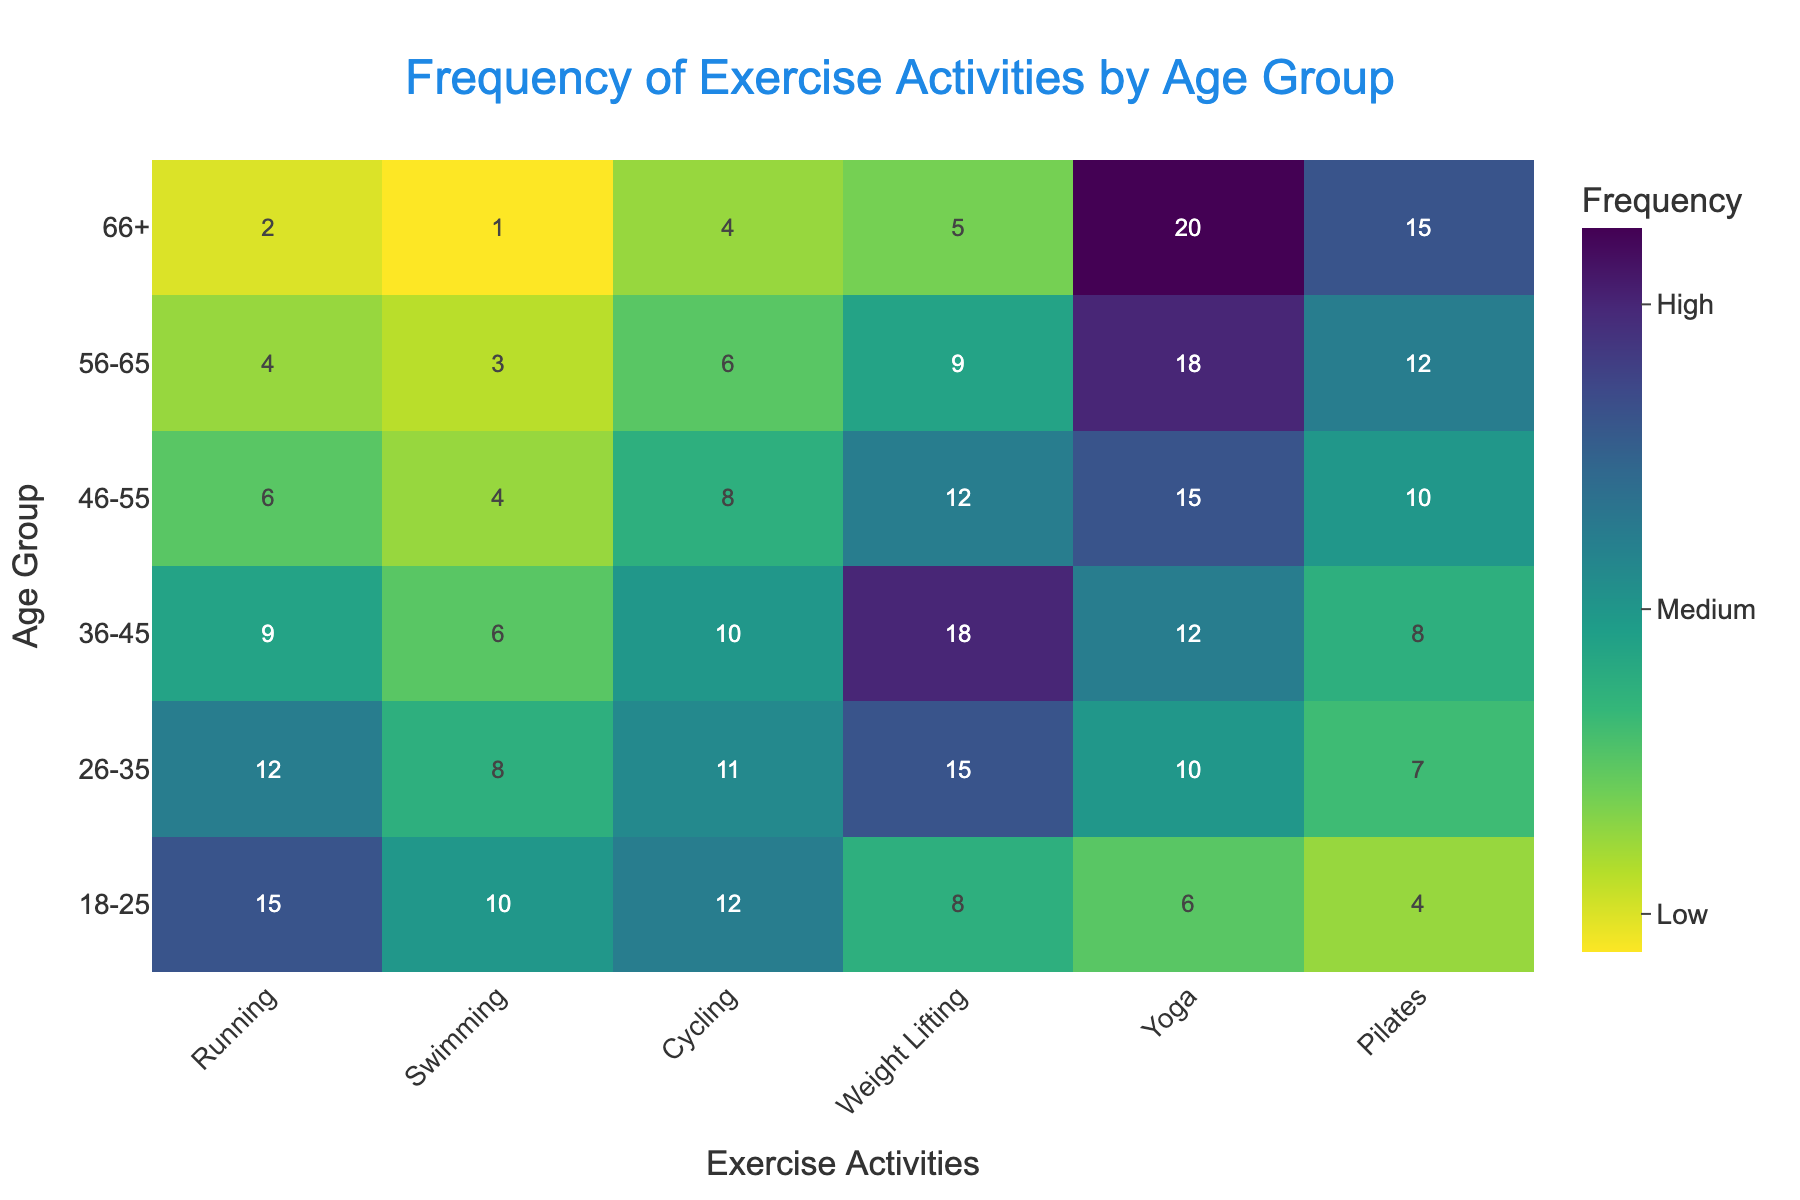What's the age group with the highest frequency of running? Look at the vertical axis for the highest frequency value in the 'Running' column
Answer: 18-25 What is the most frequent exercise activity for the age group 56-65? Locate the 56-65 age group row and find the highest value among exercise frequencies
Answer: Yoga How much more often do individuals aged 36-45 practice weight lifting compared to those aged 18-25? Compare the values in the 'Weight Lifting' column for age groups 36-45 and 18-25 (18 - 8 = 10)
Answer: 10 times more Which age group has the lowest frequency of swimming? Find the minimum value in the 'Swimming' column and identify the corresponding age group
Answer: 66+ On average, how many types of exercises do 26-35 year-olds engage in? Add all frequencies for 26-35 and divide by the number of exercise types ((12 + 8 + 11 + 15 + 10 + 7)/6 = 10.5)
Answer: 10.5 Is yoga more popular among individuals aged 46-55 or 66+? Compare the values in the 'Yoga' column for age groups 46-55 and 66+ (15 vs 20)
Answer: 66+ Which exercise activity has the highest overall frequency across all age groups? Sum the values of each column and identify the exercise with the highest total
Answer: Weight Lifting How does the frequency of cycling change from the 26-35 age group to the 66+ age group? Compare the values for 'Cycling' for 26-35 and 66+ (11 vs 4)
Answer: Decreases by 7 What's the trend in frequency of weight lifting as age increases? Observe the 'Weight Lifting' column values across age groups (8, 15, 18, 12, 9, 5)
Answer: Increases up to 36-45, then decreases 